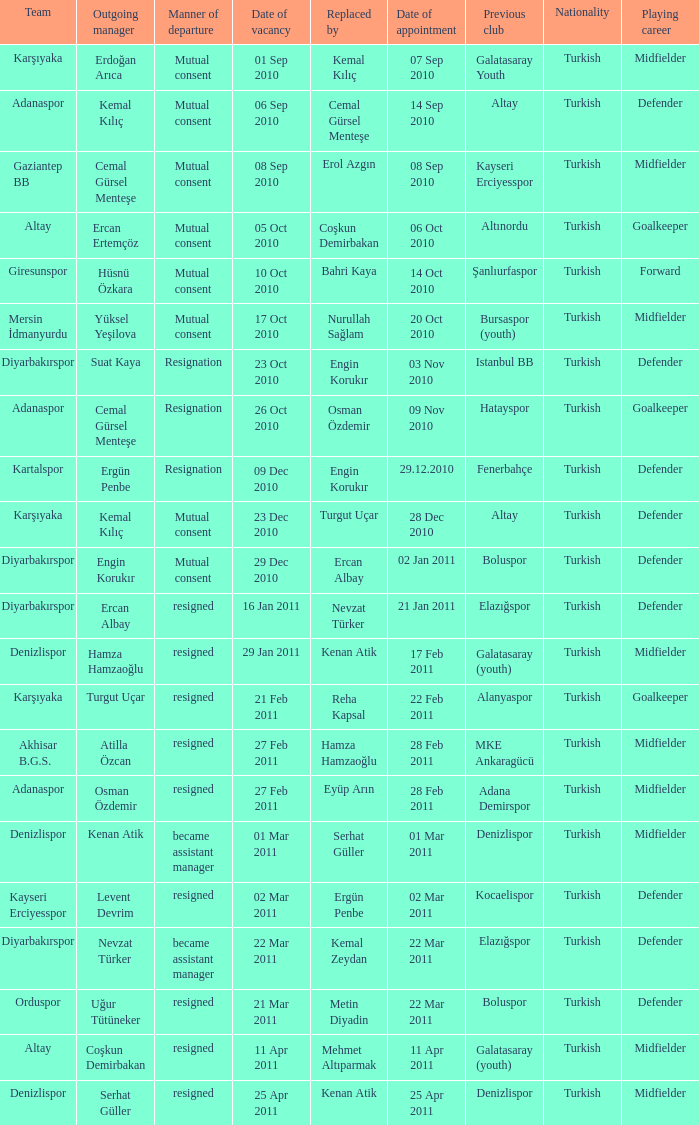When was the date of vacancy for the manager of Kartalspor?  09 Dec 2010. 